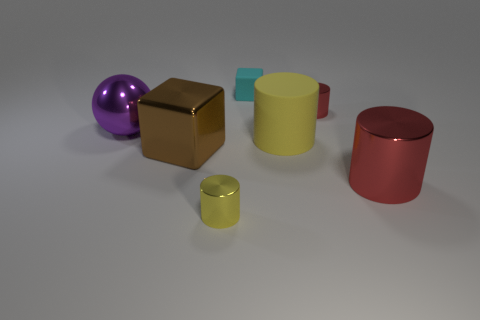Does the small yellow metal thing have the same shape as the red metallic object that is behind the purple thing?
Your answer should be compact. Yes. Are there fewer cyan matte objects that are in front of the large brown metallic block than small cyan matte blocks to the right of the small cyan rubber object?
Ensure brevity in your answer.  No. Is there any other thing that is the same shape as the small yellow metal object?
Provide a short and direct response. Yes. Do the large purple metal thing and the tiny yellow shiny object have the same shape?
Ensure brevity in your answer.  No. Are there any other things that have the same material as the small cyan object?
Offer a terse response. Yes. The metallic cube is what size?
Offer a very short reply. Large. There is a thing that is left of the matte cylinder and behind the purple object; what color is it?
Give a very brief answer. Cyan. Is the number of small green matte cylinders greater than the number of large purple objects?
Your answer should be very brief. No. What number of objects are cylinders or cylinders that are in front of the large matte object?
Your response must be concise. 4. Do the ball and the yellow matte cylinder have the same size?
Give a very brief answer. Yes. 